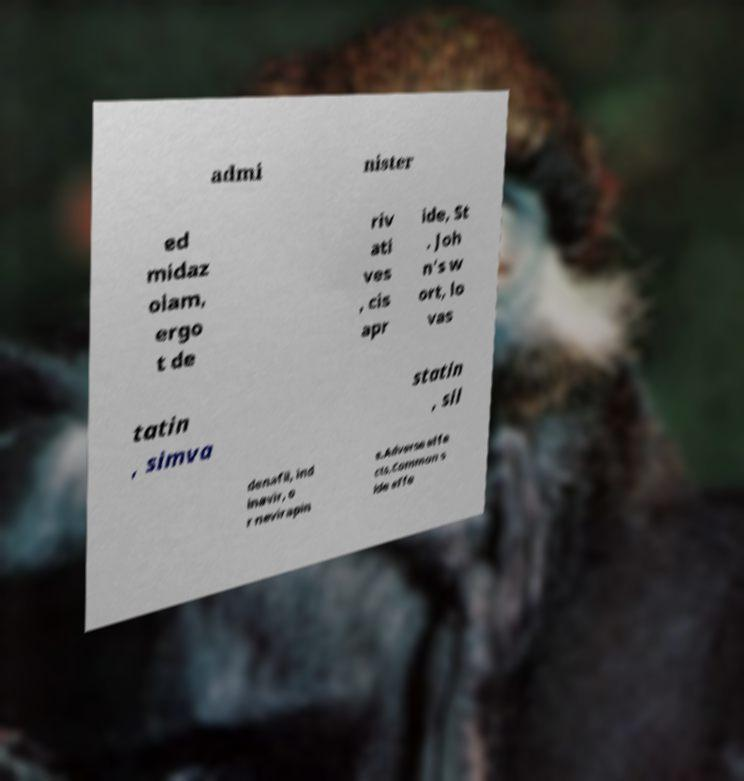Please read and relay the text visible in this image. What does it say? admi nister ed midaz olam, ergo t de riv ati ves , cis apr ide, St . Joh n's w ort, lo vas tatin , simva statin , sil denafil, ind inavir, o r nevirapin e.Adverse effe cts.Common s ide effe 